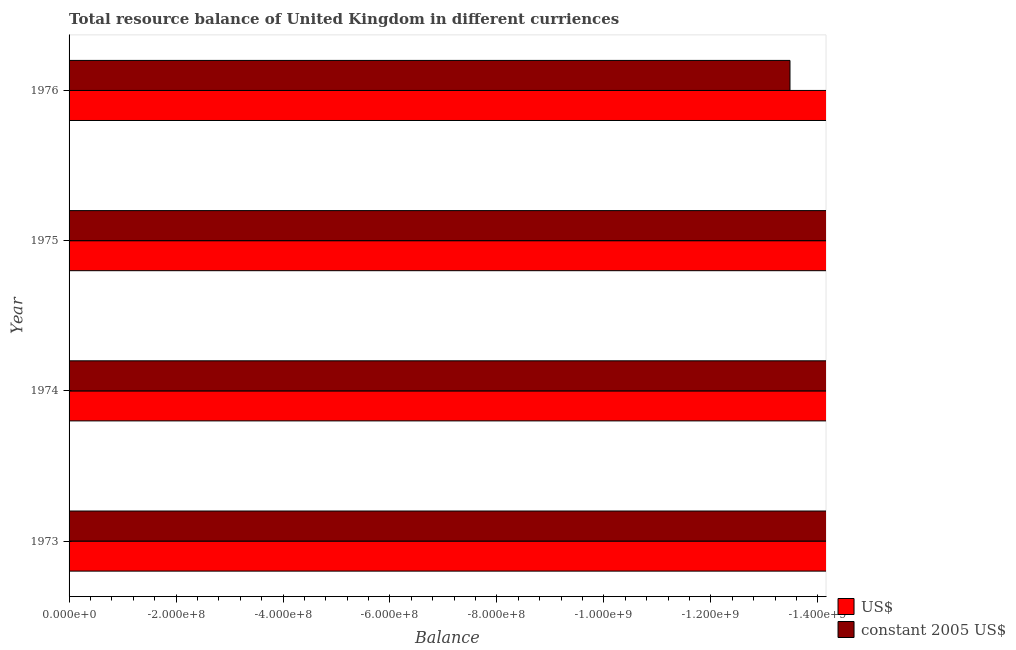How many different coloured bars are there?
Your answer should be compact. 0. How many bars are there on the 3rd tick from the top?
Ensure brevity in your answer.  0. How many bars are there on the 3rd tick from the bottom?
Keep it short and to the point. 0. What is the label of the 1st group of bars from the top?
Offer a terse response. 1976. What is the resource balance in us$ in 1976?
Offer a terse response. 0. What is the total resource balance in constant us$ in the graph?
Your answer should be very brief. 0. What is the difference between the resource balance in us$ in 1975 and the resource balance in constant us$ in 1976?
Your response must be concise. 0. What is the average resource balance in constant us$ per year?
Offer a very short reply. 0. Are all the bars in the graph horizontal?
Your answer should be compact. Yes. What is the difference between two consecutive major ticks on the X-axis?
Provide a short and direct response. 2.00e+08. Are the values on the major ticks of X-axis written in scientific E-notation?
Provide a short and direct response. Yes. Does the graph contain any zero values?
Offer a very short reply. Yes. Does the graph contain grids?
Provide a succinct answer. No. Where does the legend appear in the graph?
Ensure brevity in your answer.  Bottom right. What is the title of the graph?
Keep it short and to the point. Total resource balance of United Kingdom in different curriences. What is the label or title of the X-axis?
Give a very brief answer. Balance. What is the label or title of the Y-axis?
Offer a terse response. Year. What is the Balance in US$ in 1973?
Give a very brief answer. 0. What is the Balance of constant 2005 US$ in 1973?
Offer a very short reply. 0. What is the total Balance in constant 2005 US$ in the graph?
Your response must be concise. 0. What is the average Balance of constant 2005 US$ per year?
Ensure brevity in your answer.  0. 